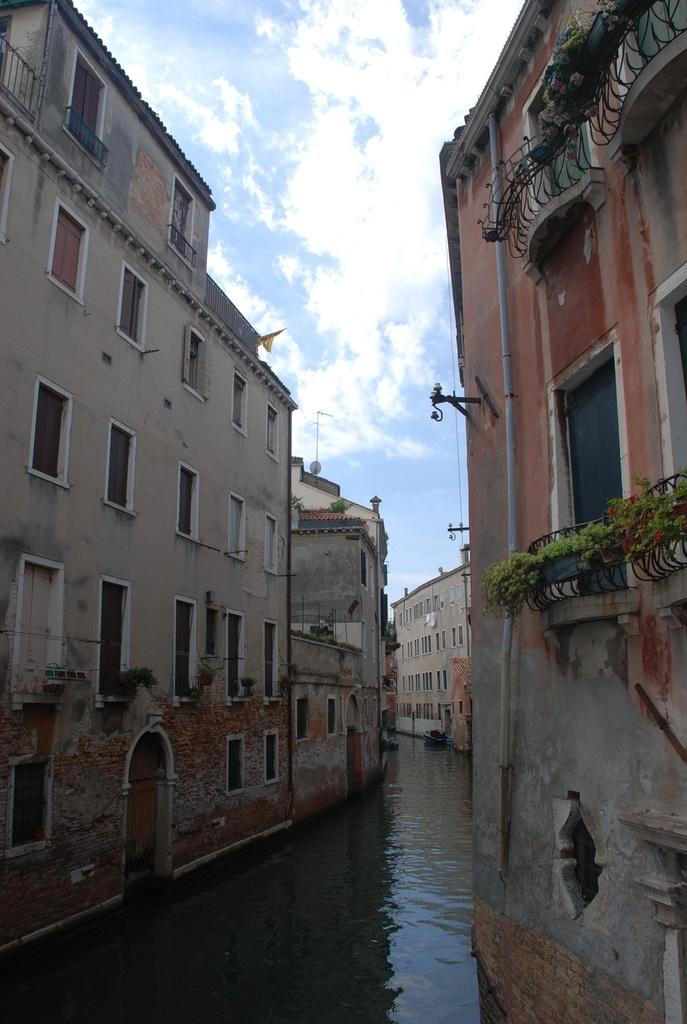What is the primary element in the image? There is water in the image. What can be seen on either side of the water? There are buildings on both sides of the water. What type of vegetation is visible in the image? There are plants visible in the image. What feature of the buildings can be seen in the image? There are windows visible in the image. What is visible in the background of the image? The sky is visible in the background of the image. What type of hospital is located near the water in the image? There is no hospital present in the image; it features water, buildings, plants, windows, and the sky. 